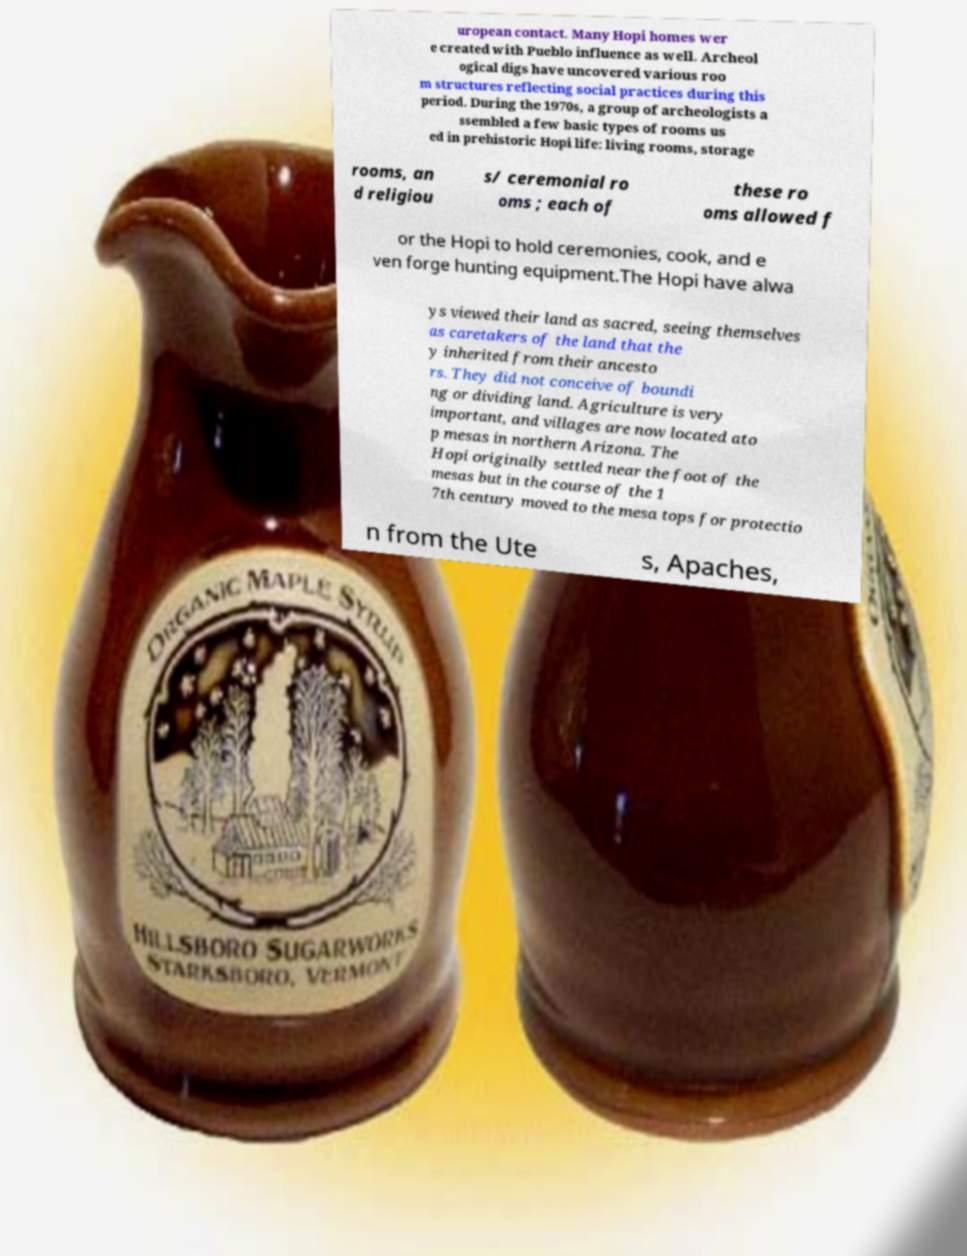Please read and relay the text visible in this image. What does it say? uropean contact. Many Hopi homes wer e created with Pueblo influence as well. Archeol ogical digs have uncovered various roo m structures reflecting social practices during this period. During the 1970s, a group of archeologists a ssembled a few basic types of rooms us ed in prehistoric Hopi life: living rooms, storage rooms, an d religiou s/ ceremonial ro oms ; each of these ro oms allowed f or the Hopi to hold ceremonies, cook, and e ven forge hunting equipment.The Hopi have alwa ys viewed their land as sacred, seeing themselves as caretakers of the land that the y inherited from their ancesto rs. They did not conceive of boundi ng or dividing land. Agriculture is very important, and villages are now located ato p mesas in northern Arizona. The Hopi originally settled near the foot of the mesas but in the course of the 1 7th century moved to the mesa tops for protectio n from the Ute s, Apaches, 